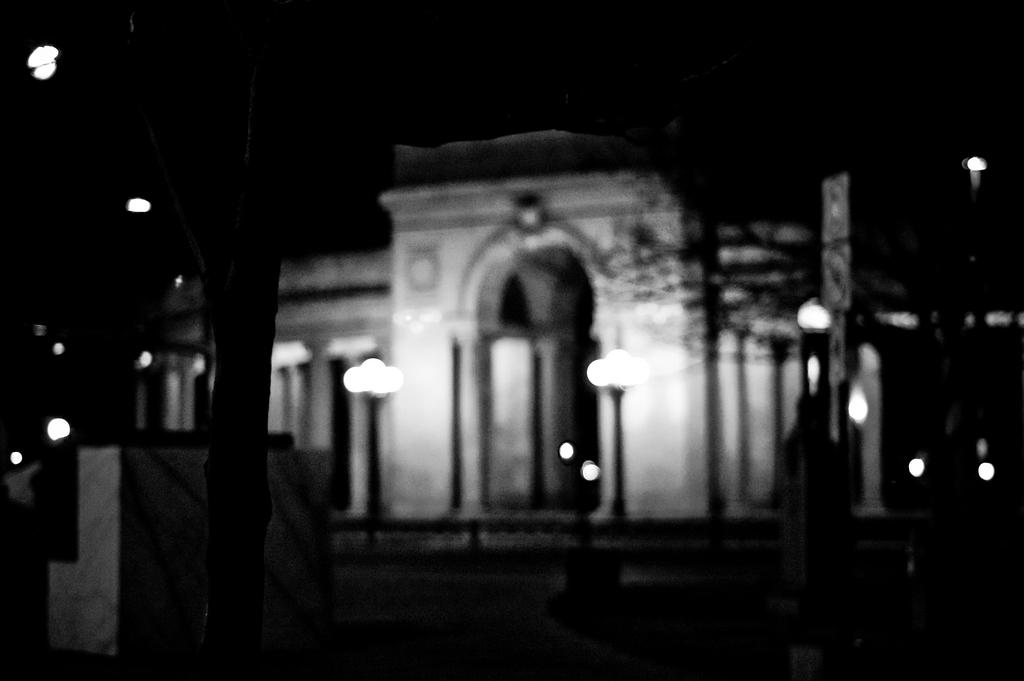What is the color scheme of the image? The image is black and white. What type of structure can be seen in the image? There is a building in the image. What natural element is present in the image? There is a tree in the image. What type of illumination is visible in the image? There are lights in the image. What type of vertical structures are present in the image? There are poles in the image. How many dimes are scattered on the ground in the image? There are no dimes present in the image. What type of land is the building situated on in the image? The provided facts do not specify the type of land the building is situated on. 